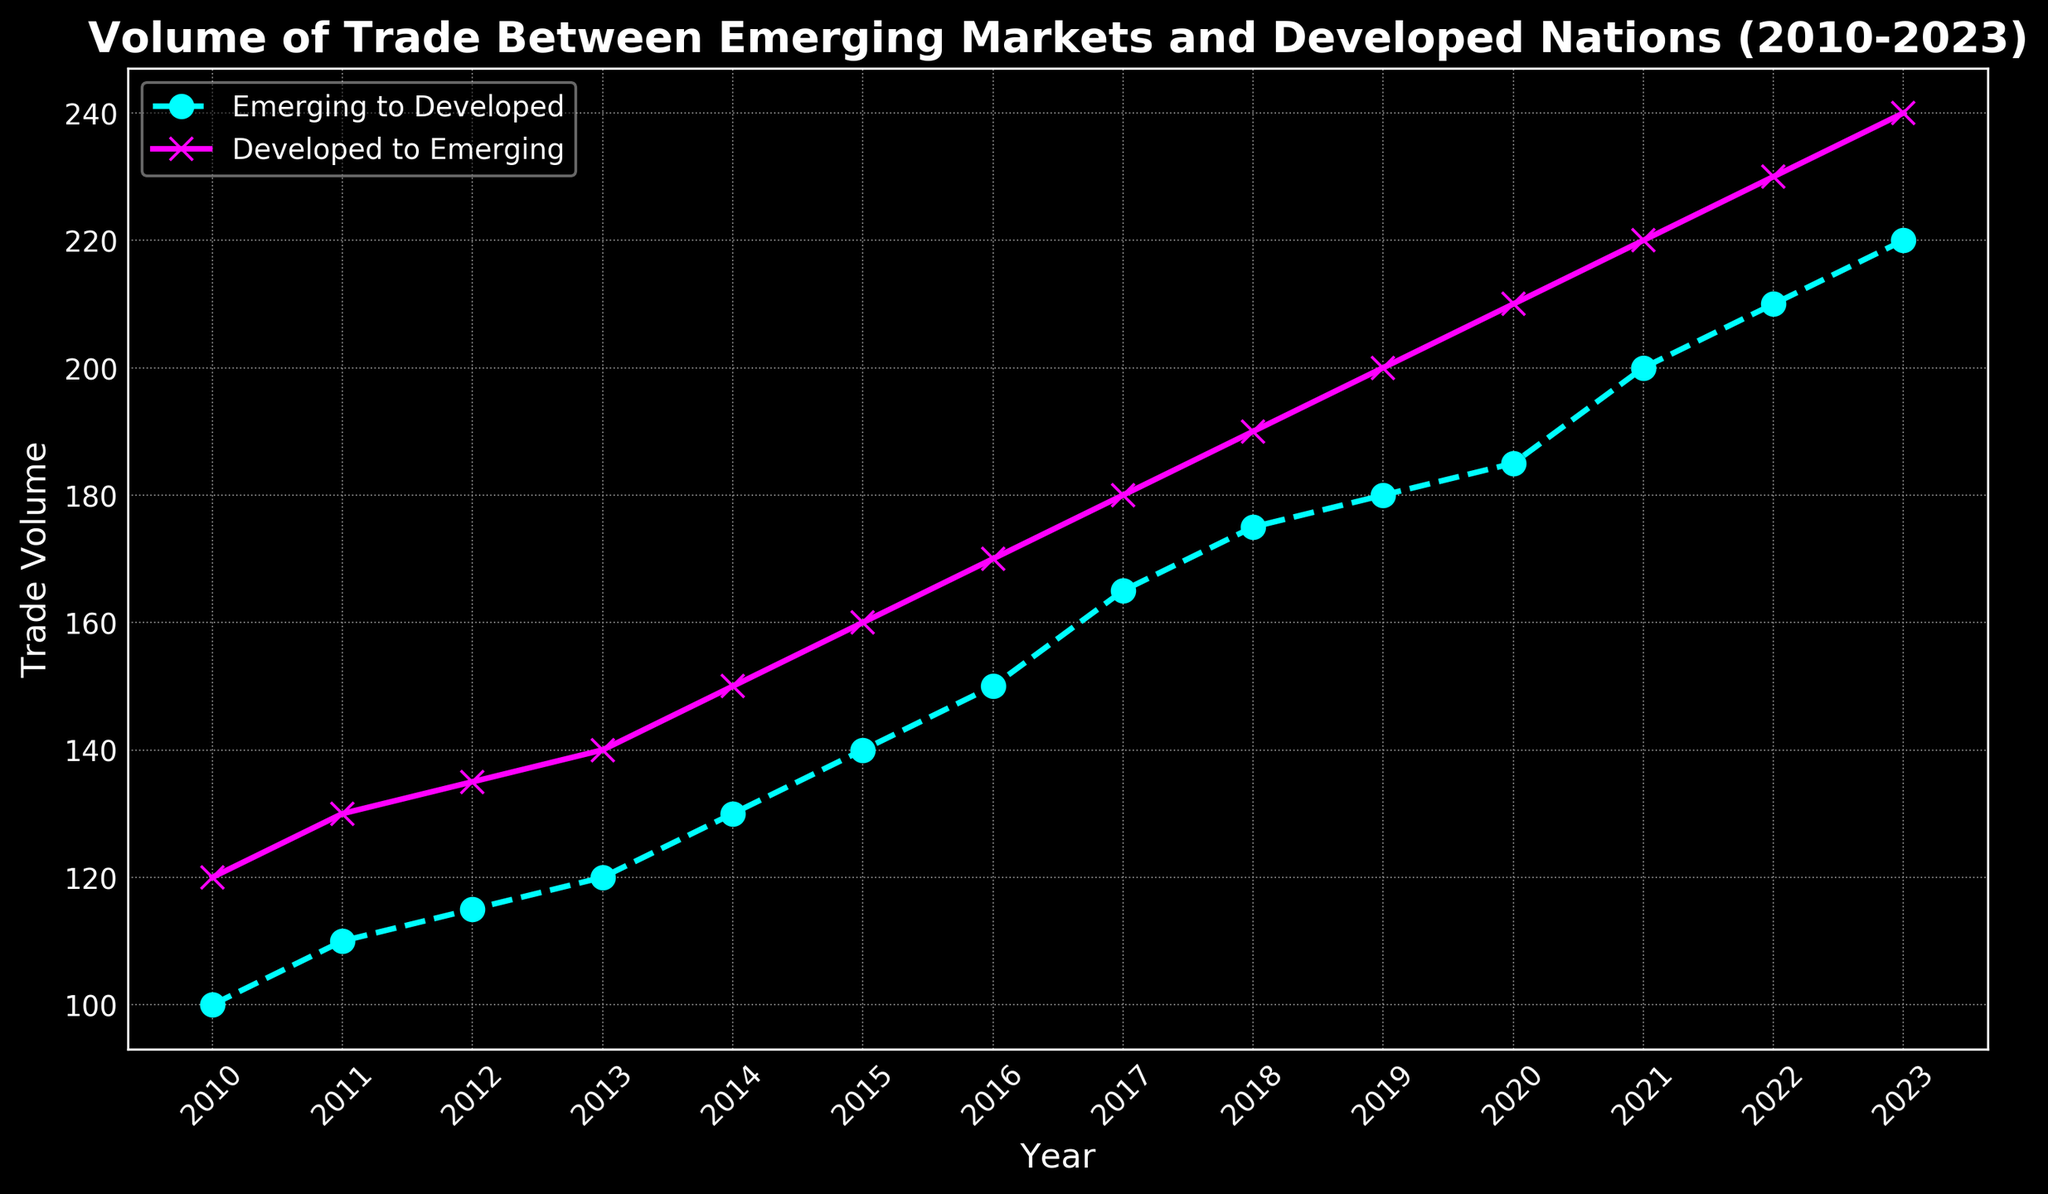How does the trade volume from Emerging to Developed nations change from 2010 to 2023? The Emerging to Developed nations' trade volume starts at 100 in 2010 and ends at 220 in 2023. By observing the line, we see a steady increase over the years.
Answer: Steadily increases Which year had the highest trade volume from Developed to Emerging nations? By looking at the data points on the plot for the Developed to Emerging nations, the highest value is at 2023 with a trade volume of 240.
Answer: 2023 Comparing the trade volumes in 2013, which direction has higher trade volume - Emerging to Developed or Developed to Emerging? By referring to the figure, the Developed to Emerging nations trade volume in 2013 is 140, while Emerging to Developed is 120, making the Developed to Emerging volume higher in 2013.
Answer: Developed to Emerging What is the difference in trade volume from 2011 to 2015 for Emerging to Developed nations? The trade volume in 2011 for Emerging to Developed is 110, and in 2015 it is 140. The difference is calculated as 140 - 110.
Answer: 30 What is the average trade volume from Developed to Emerging nations over the entire period (2010-2023)? Add all the yearly trade volumes from 2010 to 2023 and then divide by the number of years (14). (120 + 130 + 135 + 140 + 150 + 160 + 170 + 180 + 190 + 200 + 210 + 220 + 230 + 240) / 14 = 186.43
Answer: 186.43 By how much did the trade volume increase from 2021 to 2023 for Emerging to Developed nations? The trade volume for Emerging to Developed nations in 2021 is 200 and in 2023 is 220. The increase is calculated as 220 - 200.
Answer: 20 What is the peak-to-peak difference in trade volumes between Emerging to Developed and Developed to Emerging nations for any given year during 2010-2023? For the year 2023, the trade volume for Emerging to Developed is 220 and for Developed to Emerging is 240. The peak-to-peak difference is 240 - 220.
Answer: 20 Compare the trade volumes in 2018 for both directions. How much higher is one over the other? The trade volume for Emerging to Developed in 2018 is 175, while for Developed to Emerging it is 190. The difference is 190 - 175.
Answer: 15 What trends can be observed from the size and pattern of markers for both series on the plot? The markers for Emerging to Developed (cyan, 'o', dashed line) and Developed to Emerging (magenta, 'x', solid line) both show an increasing trend over the years, indicating growth in trade volume for both directions.
Answer: Increasing trend Calculate the total trade volume from Emerging to Developed nations over the entire period (sum of all years). Sum the values for Emerging to Developed from 2010 to 2023. (100 + 110 + 115 + 120 + 130 + 140 + 150 + 165 + 175 + 180 + 185 + 200 + 210 + 220) = 2400.
Answer: 2400 